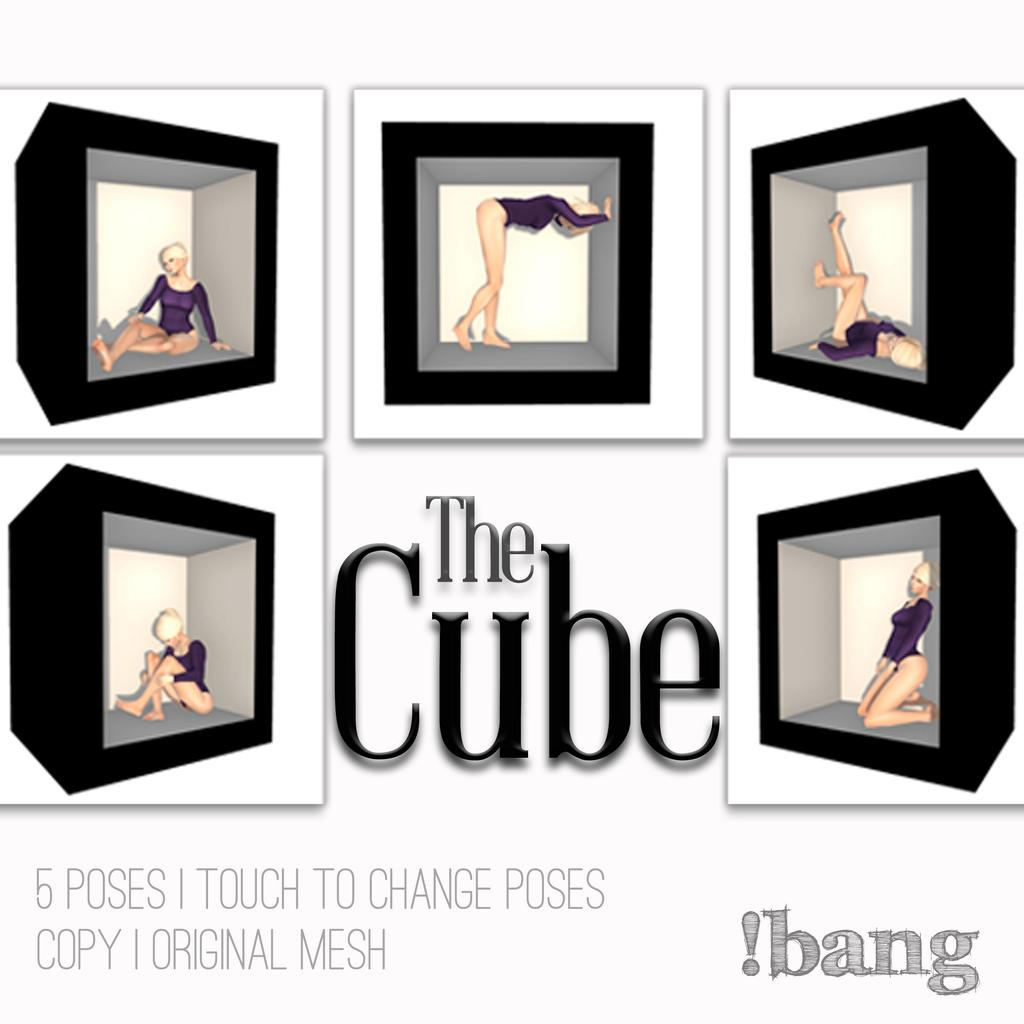<image>
Provide a brief description of the given image. A book named The Cube 5 Poses 1 Touch to Change Poses. 